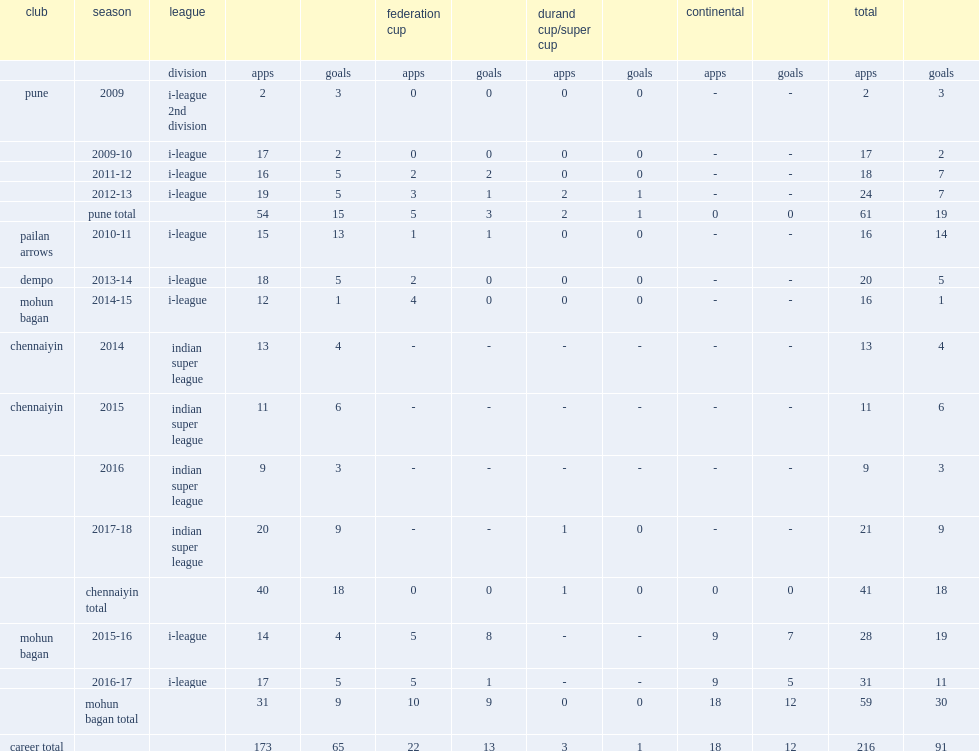Which league did jeje appear for chennaiyin in the 2015 season? Indian super league. 